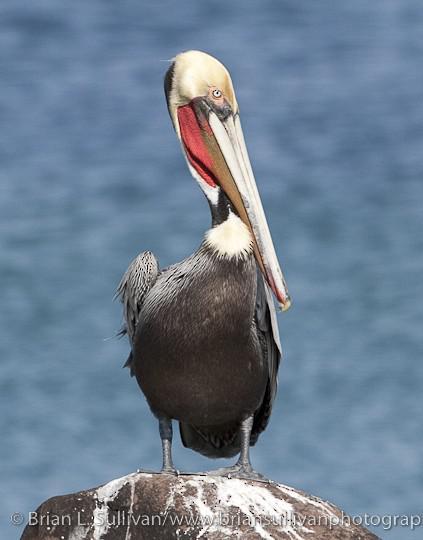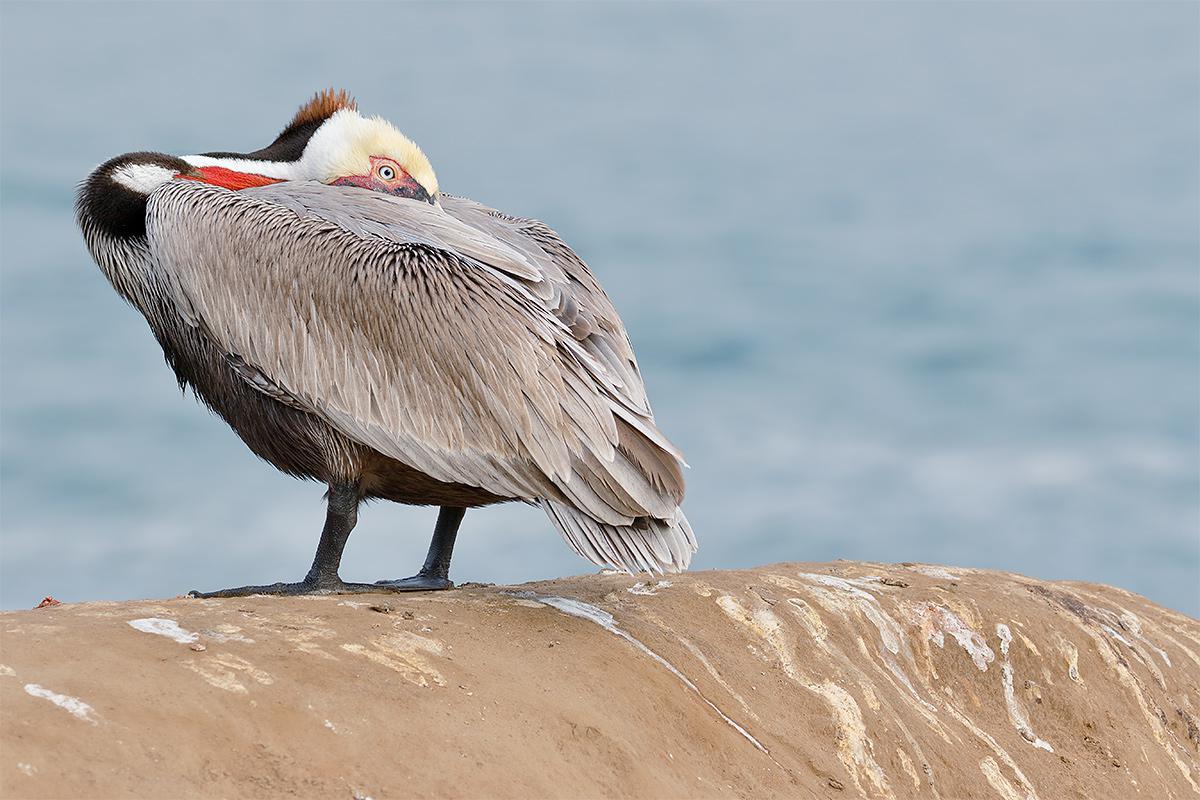The first image is the image on the left, the second image is the image on the right. For the images shown, is this caption "There are only two birds that are standing." true? Answer yes or no. Yes. The first image is the image on the left, the second image is the image on the right. For the images shown, is this caption "Each image shows a single pelican standing on its legs." true? Answer yes or no. Yes. 